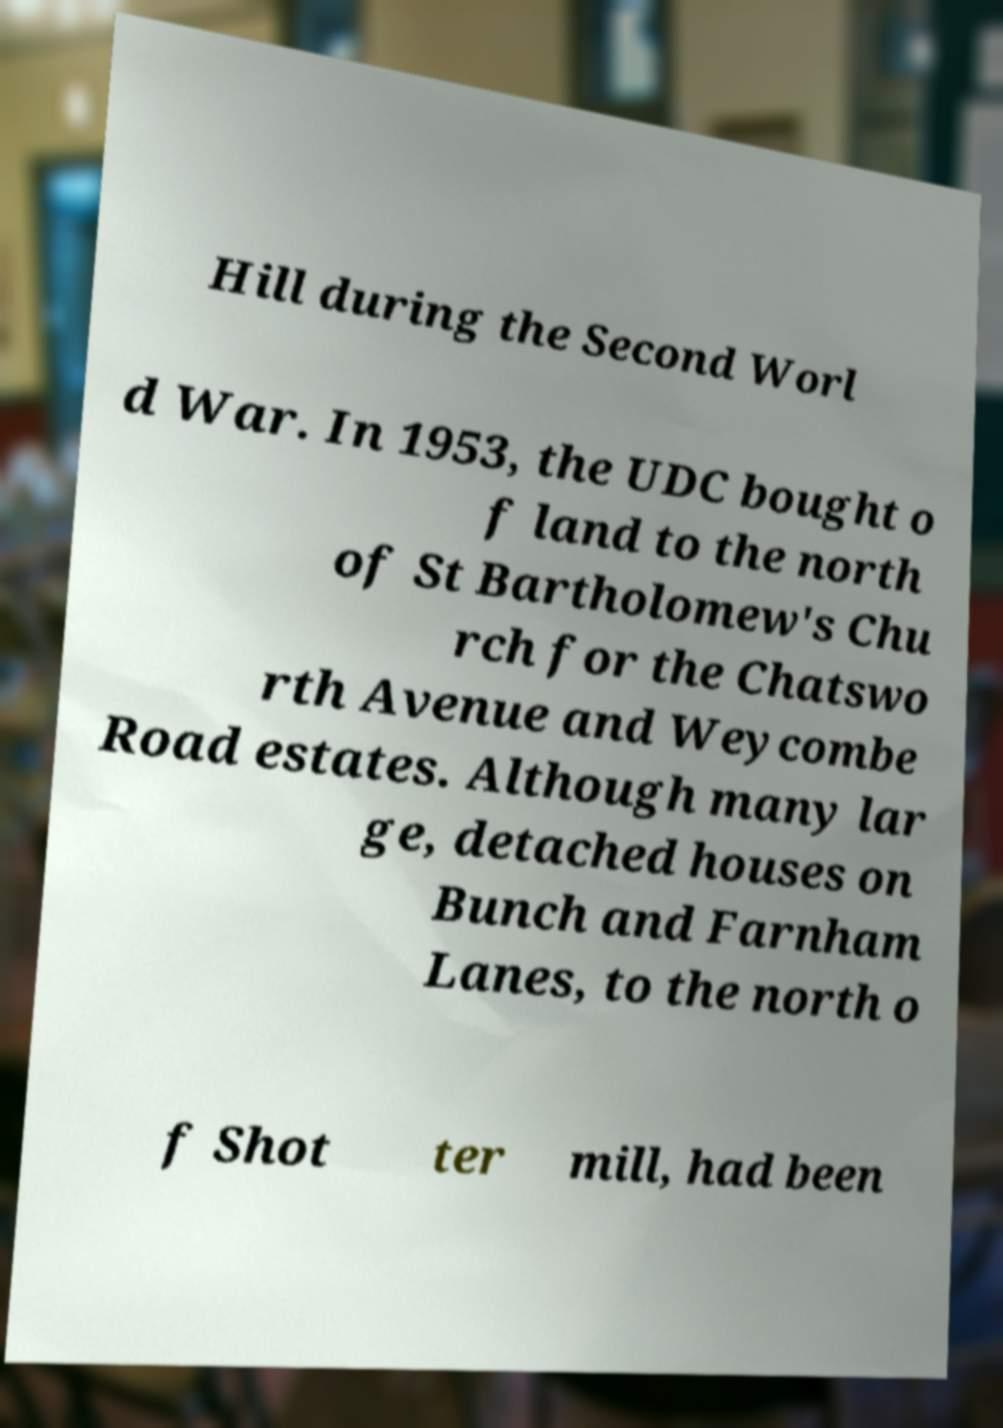Can you accurately transcribe the text from the provided image for me? Hill during the Second Worl d War. In 1953, the UDC bought o f land to the north of St Bartholomew's Chu rch for the Chatswo rth Avenue and Weycombe Road estates. Although many lar ge, detached houses on Bunch and Farnham Lanes, to the north o f Shot ter mill, had been 